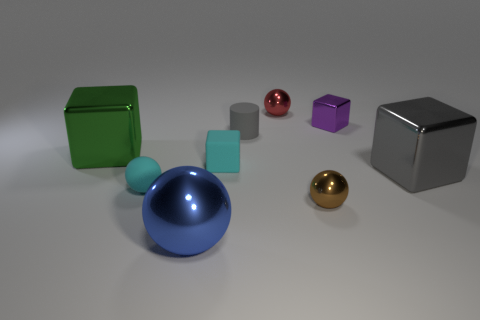What size is the gray matte cylinder that is to the left of the small shiny ball behind the cyan matte object that is on the right side of the blue metallic sphere?
Provide a succinct answer. Small. What number of things are either small things that are to the right of the tiny gray cylinder or green blocks?
Your response must be concise. 4. There is a small metal sphere in front of the green thing; how many big gray metallic cubes are in front of it?
Your response must be concise. 0. Are there more gray rubber cylinders on the right side of the big gray thing than blocks?
Your answer should be compact. No. What is the size of the thing that is both left of the big blue shiny sphere and behind the small cyan matte sphere?
Your answer should be very brief. Large. What is the shape of the thing that is both on the right side of the small gray cylinder and in front of the small cyan rubber sphere?
Provide a short and direct response. Sphere. There is a gray object that is on the left side of the tiny red metal object that is behind the tiny cylinder; is there a large green block right of it?
Keep it short and to the point. No. What number of things are shiny spheres that are to the left of the red shiny thing or small things that are to the right of the big ball?
Your response must be concise. 6. Are the small sphere on the left side of the small gray rubber thing and the large gray cube made of the same material?
Give a very brief answer. No. There is a ball that is to the right of the cyan cube and in front of the small red thing; what material is it made of?
Provide a short and direct response. Metal. 